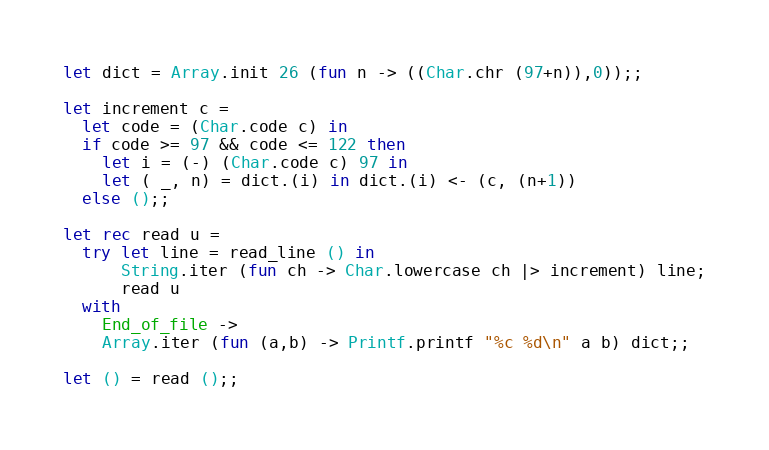Convert code to text. <code><loc_0><loc_0><loc_500><loc_500><_OCaml_>let dict = Array.init 26 (fun n -> ((Char.chr (97+n)),0));;

let increment c =
  let code = (Char.code c) in
  if code >= 97 && code <= 122 then
    let i = (-) (Char.code c) 97 in
    let ( _, n) = dict.(i) in dict.(i) <- (c, (n+1))
  else ();;

let rec read u =
  try let line = read_line () in
      String.iter (fun ch -> Char.lowercase ch |> increment) line;
      read u
  with
    End_of_file ->
    Array.iter (fun (a,b) -> Printf.printf "%c %d\n" a b) dict;;

let () = read ();;</code> 